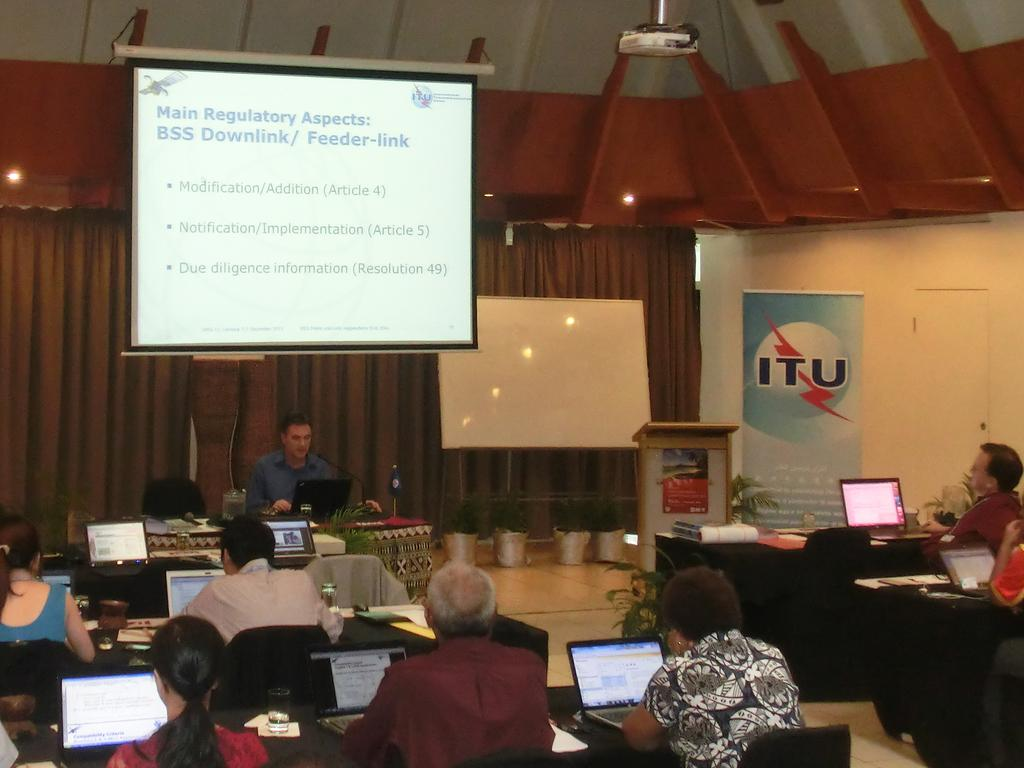<image>
Summarize the visual content of the image. a man giving a presentation about BBS donwlink/ feeder-link to room full of people on their computers 